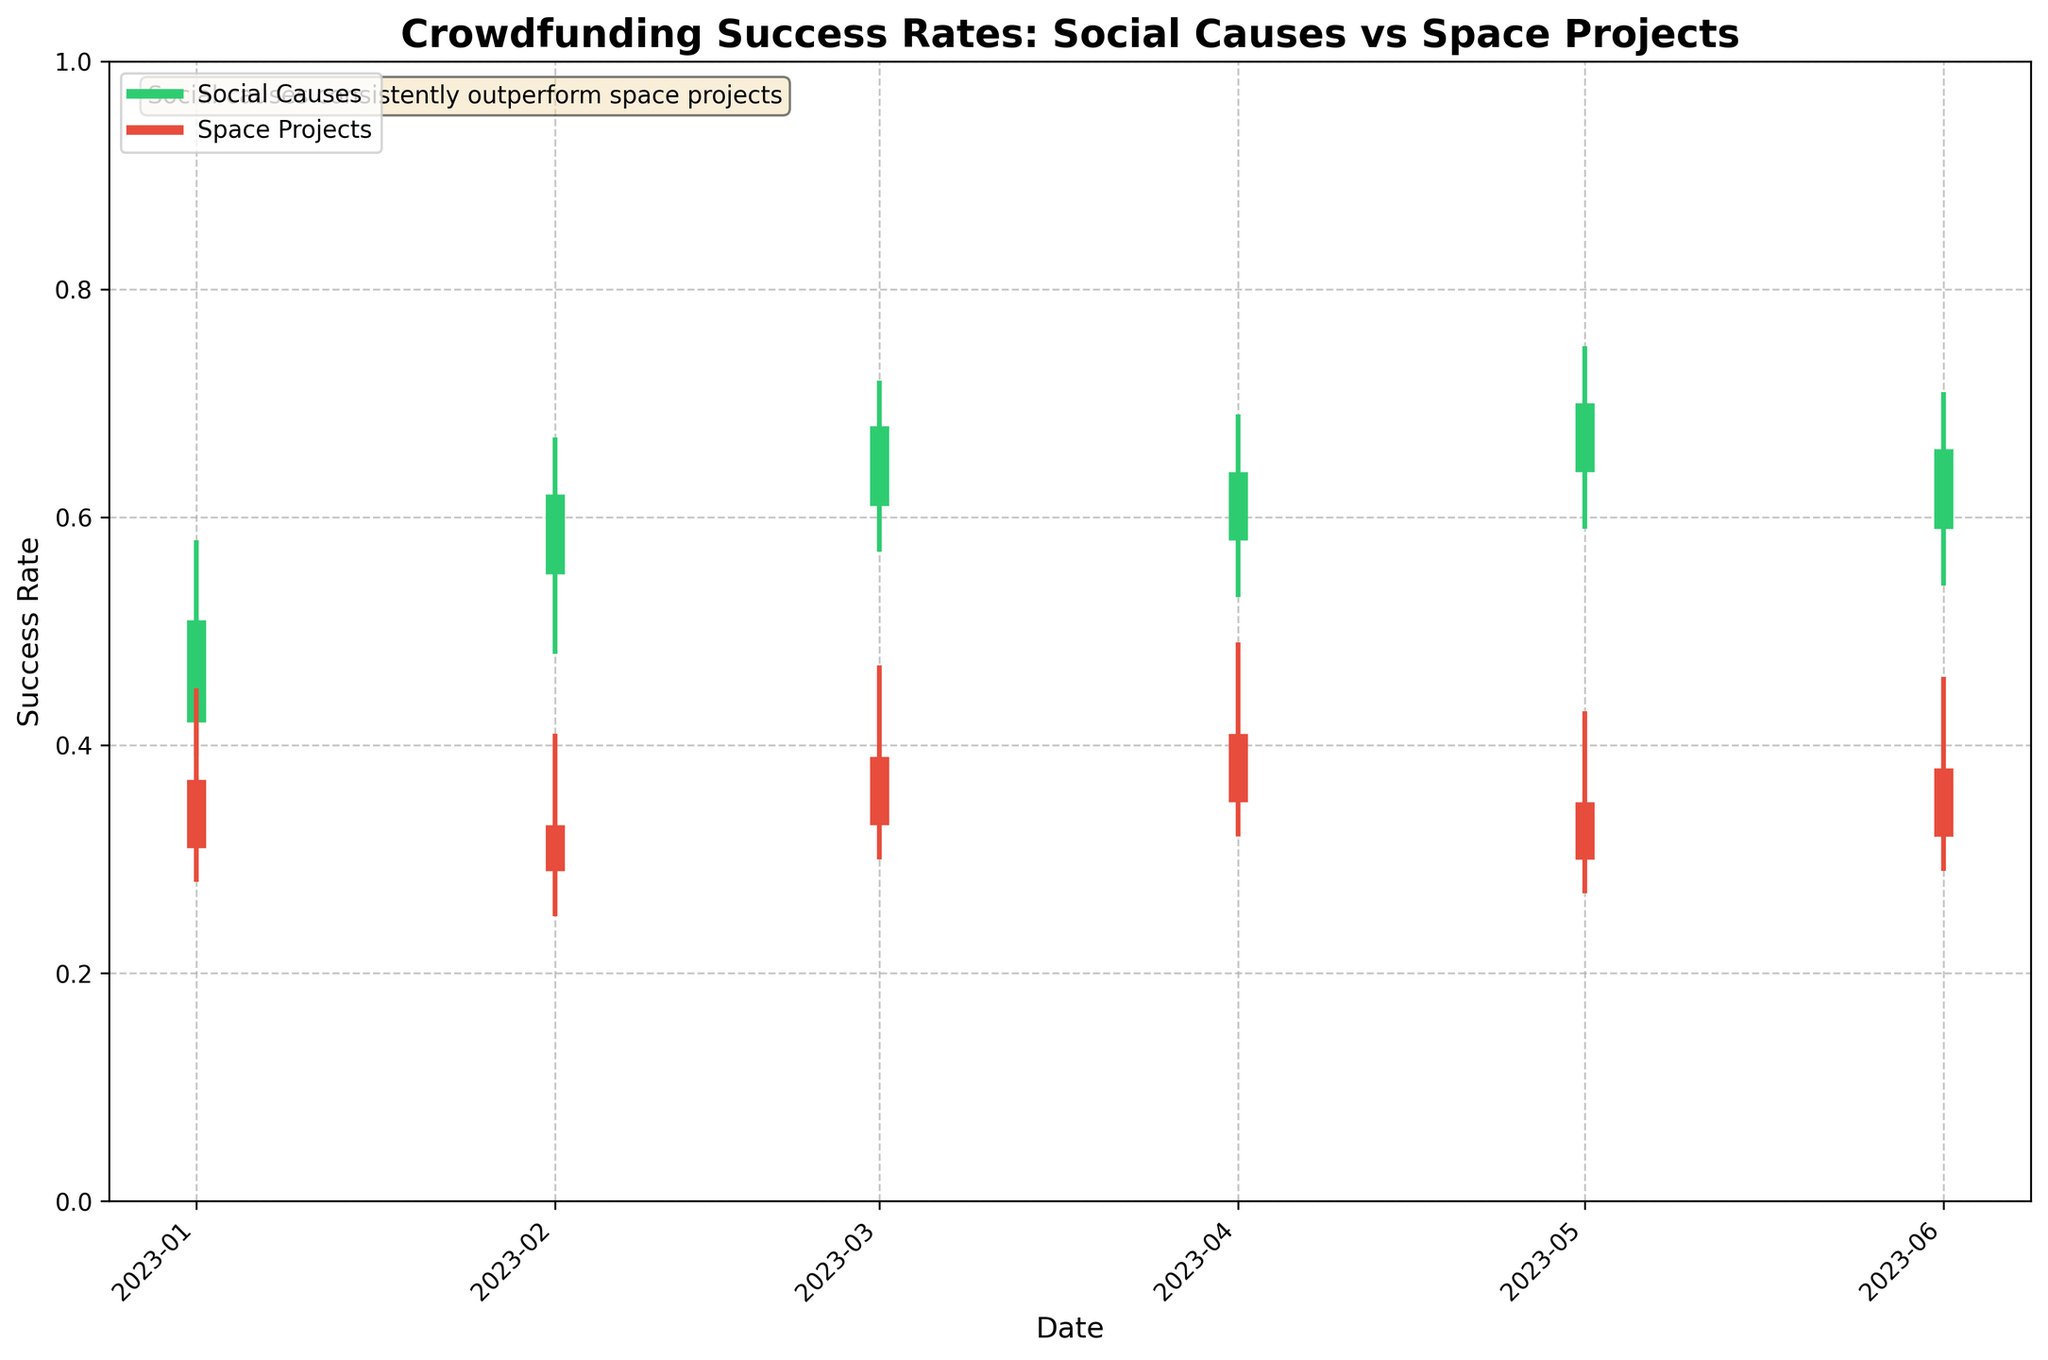What is the title of the figure? The title can be found at the top of the chart. It is designed to give a quick overview of what the chart is representing.
Answer: Crowdfunding Success Rates: Social Causes vs Space Projects What are the colors used to differentiate social causes and space projects? You can identify the colors by looking at the legend or by examining the different sections of the chart.
Answer: Green and Red In which month did space exploration projects have the lowest Close success rate? By examining the red segments corresponding to the closing rates of space-related projects across the months, the lowest can be identified.
Answer: January 2023 Which social cause had the highest High success rate and what was that rate? Look at the height of the green vertical lines representing the High values across the months; the highest one indicates this value.
Answer: Education Equity, 0.72 Compare the performance of social causes and space projects in May 2023. Which category performed better and by how much? By comparing both sets of OHLC data (Poverty Alleviation for social causes and Lunar Base for space projects) in May, we can find the difference in the performance. Poverty Alleviation's Close rate is 0.70, and Lunar Base's is 0.35.
Answer: Social causes performed better by 0.35 What is the trend for social causes success rates from January to June 2023? Observing the green bars' Close values, identify if there is an increasing, decreasing, or stable trend.
Answer: Increasing How do the High values of space projects in June 2023 compare to the Low values of social causes in the same month? Check the red High value of Space Tourism in June (0.46) and compare it with the green Low value of Clean Water Access in June (0.54).
Answer: Lower What is the average Close success rate of space projects from January to June 2023? Sum the Close rates for each month’s space project and divide by the number of months (6). (0.37+0.33+0.39+0.41+0.35+0.38)=2.23; 2.23/6=0.37
Answer: 0.37 How does the opening success rate of Education Equity in March compare to the closing success rate of Climate Action in April? Compare the green Open value for Education Equity (0.61) with the green Close value for Climate Action (0.64).
Answer: Climate Action is higher by 0.03 Which month had the smallest High-Low range for space projects, and what was that range? Calculate the difference between High and Low for each month’s space project and identify the smallest value. For January: 0.45-0.28=0.17, February: 0.41-0.25=0.16, March: 0.47-0.30=0.17, April: 0.49-0.32=0.17, May: 0.43-0.27=0.16, June: 0.46-0.29=0.17. Smallest range is 0.16 in February and May.
Answer: February and May, 0.16 